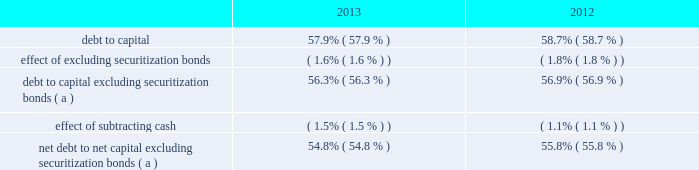Human capital management strategic imperative entergy engaged in a strategic imperative intended to optimize the organization through a process known as human capital management .
In july 2013 management completed a comprehensive review of entergy 2019s organization design and processes .
This effort resulted in a new internal organization structure , which resulted in the elimination of approximately 800 employee positions .
Entergy incurred approximately $ 110 million in costs in 2013 associated with this phase of human capital management , primarily implementation costs , severance expenses , pension curtailment losses , special termination benefits expense , and corporate property , plant , and equipment impairments .
In december 2013 , entergy deferred for future recovery approximately $ 45 million of these costs , as approved by the apsc and the lpsc .
See note 2 to the financial statements for details of the deferrals and note 13 to the financial statements for details of the restructuring charges .
Liquidity and capital resources this section discusses entergy 2019s capital structure , capital spending plans and other uses of capital , sources of capital , and the cash flow activity presented in the cash flow statement .
Capital structure entergy 2019s capitalization is balanced between equity and debt , as shown in the table. .
( a ) calculation excludes the arkansas , louisiana , and texas securitization bonds , which are non-recourse to entergy arkansas , entergy louisiana , and entergy texas , respectively .
Net debt consists of debt less cash and cash equivalents .
Debt consists of notes payable and commercial paper , capital lease obligations , and long-term debt , including the currently maturing portion .
Capital consists of debt , common shareholders 2019 equity , and subsidiaries 2019 preferred stock without sinking fund .
Net capital consists of capital less cash and cash equivalents .
Entergy uses the debt to capital ratios excluding securitization bonds in analyzing its financial condition and believes they provide useful information to its investors and creditors in evaluating entergy 2019s financial condition because the securitization bonds are non-recourse to entergy , as more fully described in note 5 to the financial statements .
Entergy also uses the net debt to net capital ratio excluding securitization bonds in analyzing its financial condition and believes it provides useful information to its investors and creditors in evaluating entergy 2019s financial condition because net debt indicates entergy 2019s outstanding debt position that could not be readily satisfied by cash and cash equivalents on hand .
Long-term debt , including the currently maturing portion , makes up most of entergy 2019s total debt outstanding .
Following are entergy 2019s long-term debt principal maturities and estimated interest payments as of december 31 , 2013 .
To estimate future interest payments for variable rate debt , entergy used the rate as of december 31 , 2013 .
The amounts below include payments on the entergy louisiana and system energy sale-leaseback transactions , which are included in long-term debt on the balance sheet .
Entergy corporation and subsidiaries management's financial discussion and analysis .
What is the percent change in debt to capital from 2012 to 2013? 
Computations: ((58.7 - 57.9) / 57.9)
Answer: 0.01382. 